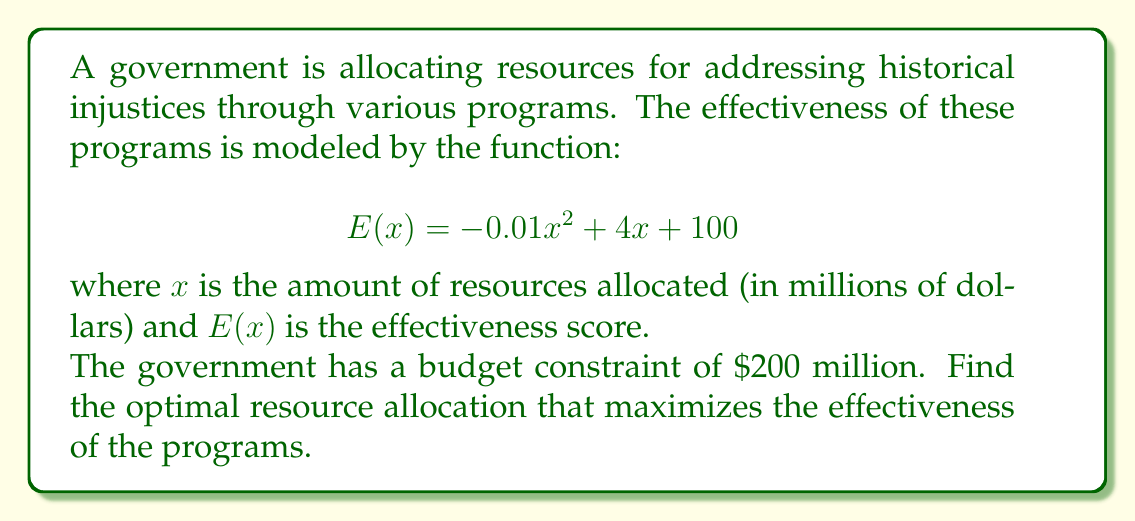Help me with this question. To solve this optimization problem, we need to find the maximum value of $E(x)$ subject to the constraint $0 \leq x \leq 200$.

1. First, let's find the critical points by taking the derivative of $E(x)$ and setting it to zero:

   $$E'(x) = -0.02x + 4$$
   $$-0.02x + 4 = 0$$
   $$-0.02x = -4$$
   $$x = 200$$

2. The critical point $x = 200$ coincides with our upper constraint, so we need to evaluate $E(x)$ at both endpoints of our interval $[0, 200]$ and at the critical point:

   $$E(0) = 100$$
   $$E(200) = -0.01(200)^2 + 4(200) + 100 = 500$$

3. Comparing these values, we see that the maximum occurs at $x = 200$.

4. To verify this is indeed a maximum, we can check the second derivative:

   $$E''(x) = -0.02$$

   Since $E''(x)$ is negative for all $x$, the function is concave down, confirming that $x = 200$ gives a maximum.

Therefore, the optimal resource allocation is to use the entire budget of $200 million.
Answer: $200 million 